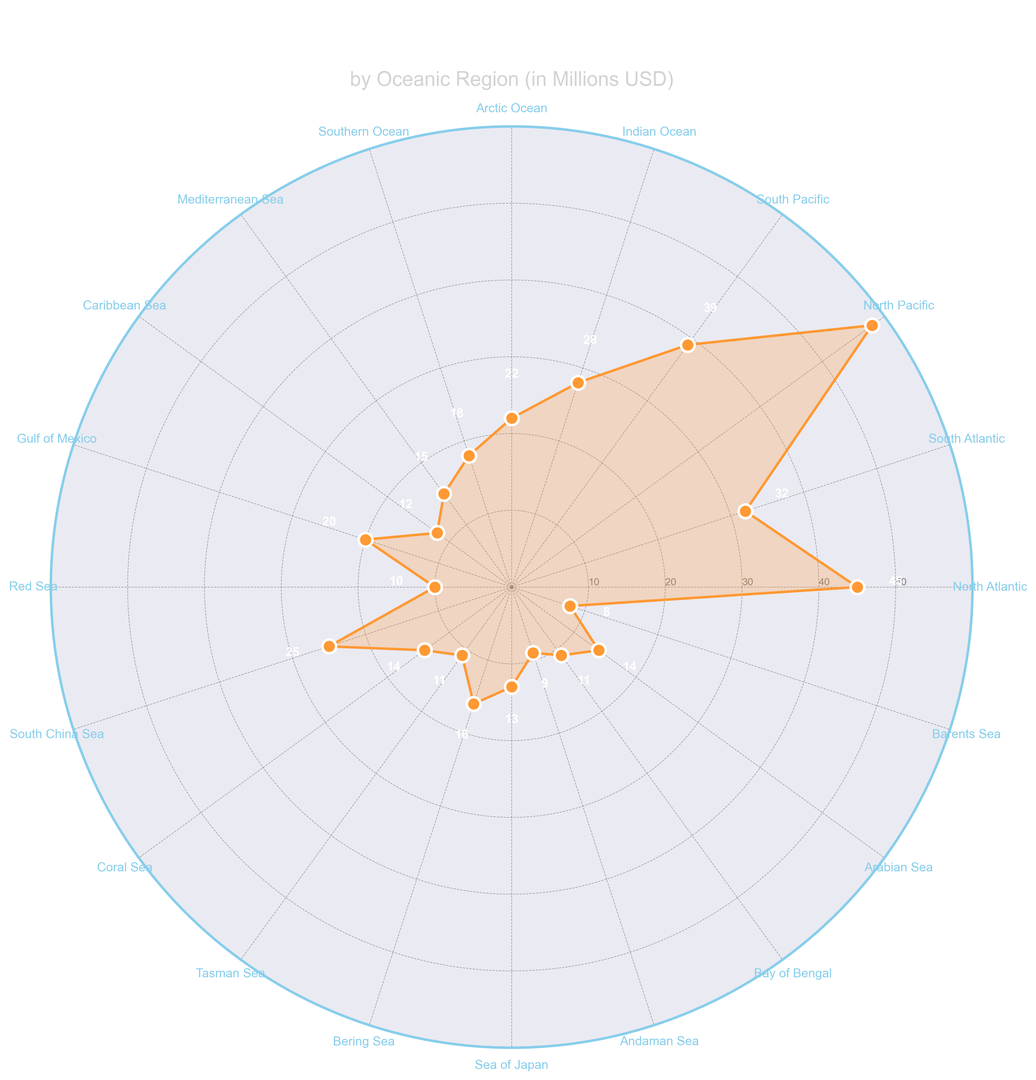Which region received the highest funding? The region with the highest funding will be the outermost point on the radar plot. The North Pacific stands out as the furthest from the center, indicating it received the highest funding, which is 58 million USD.
Answer: North Pacific Which region received the lowest funding? The region with the lowest funding will be the innermost point on the radar plot. The Barents Sea is the closest to the center, indicating it received the lowest funding, which is 8 million USD.
Answer: Barents Sea What is the difference in funding between the North Pacific and the South Pacific? Locate the points for North Pacific and South Pacific on the radar plot. North Pacific is at 58 million USD and South Pacific is at 39 million USD. The difference between them is 58 - 39 = 19 million USD.
Answer: 19 million USD Which regions received exactly more than 40 million USD? The regions with funding beyond the 40 million USD mark will be beyond the fourth ring on the radar plot. The North Atlantic (45 million USD) and North Pacific (58 million USD) exceed this threshold.
Answer: North Atlantic, North Pacific What is the average funding for the Arctic Ocean, Southern Ocean, and Mediterranean Sea? Locate the points for Arctic Ocean, Southern Ocean, and Mediterranean Sea. Their funding are 22 million USD, 18 million USD, and 15 million USD respectively. The average funding is (22 + 18 + 15)/3 = 55/3 ≈ 18.33 million USD.
Answer: 18.33 million USD How does the funding for the Gulf of Mexico compare to the Red Sea? Locate the points for Gulf of Mexico and Red Sea. Gulf of Mexico has 20 million USD and Red Sea has 10 million USD. Gulf of Mexico received double the funding of the Red Sea.
Answer: Double Which two regions have the closest funding amounts? Look for regions with nearly overlapping points on the radar plot. The Mediterranean Sea and Arabian Sea both have funding amounts close to one another: 15 million USD and 14 million USD respectively, differing by only 1 million USD.
Answer: Mediterranean Sea and Arabian Sea What's the combined funding for the Caribbean Sea and Coral Sea? Locate the points for Caribbean Sea and Coral Sea. They have 12 million USD and 14 million USD respectively. The combined funding is 12 + 14 = 26 million USD.
Answer: 26 million USD Which region's funding is exactly halfway between the highest and lowest funding? The highest funding is for the North Pacific with 58 million USD and the lowest is for the Barents Sea with 8 million USD. Halfway is (58 + 8)/2 = 33 million USD. The South Atlantic, with 32 million USD, is very close to this value.
Answer: South Atlantic How many regions received funding of 12 million USD or less? Identify all regions with funding at or below the second circle, representing 12 million USD. The regions are: Caribbean Sea (12), Red Sea (10), Tasman Sea (11), Bay of Bengal (11), Andaman Sea (9), and Barents Sea (8). Count these regions. There are 6 regions.
Answer: 6 